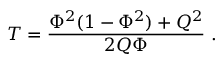<formula> <loc_0><loc_0><loc_500><loc_500>T = { \frac { \Phi ^ { 2 } ( 1 - \Phi ^ { 2 } ) + Q ^ { 2 } } { 2 Q \Phi } } \ .</formula> 